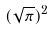Convert formula to latex. <formula><loc_0><loc_0><loc_500><loc_500>( \sqrt { \pi } ) ^ { 2 }</formula> 